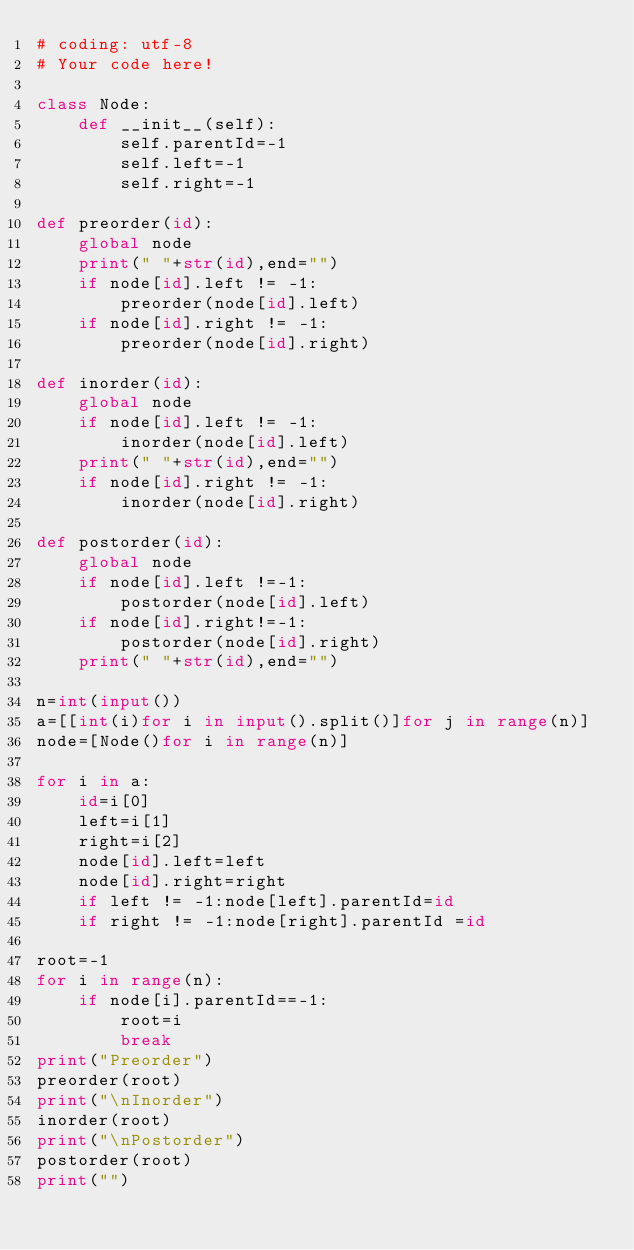Convert code to text. <code><loc_0><loc_0><loc_500><loc_500><_Python_># coding: utf-8
# Your code here!

class Node:
    def __init__(self):
        self.parentId=-1
        self.left=-1
        self.right=-1

def preorder(id):
    global node
    print(" "+str(id),end="")
    if node[id].left != -1:
        preorder(node[id].left)
    if node[id].right != -1:
        preorder(node[id].right)
    
def inorder(id):
    global node
    if node[id].left != -1:
        inorder(node[id].left)
    print(" "+str(id),end="")
    if node[id].right != -1:
        inorder(node[id].right)

def postorder(id):
    global node
    if node[id].left !=-1:
        postorder(node[id].left)
    if node[id].right!=-1:
        postorder(node[id].right)
    print(" "+str(id),end="")

n=int(input())
a=[[int(i)for i in input().split()]for j in range(n)]
node=[Node()for i in range(n)]

for i in a:
    id=i[0]
    left=i[1]
    right=i[2]
    node[id].left=left
    node[id].right=right
    if left != -1:node[left].parentId=id
    if right != -1:node[right].parentId =id

root=-1
for i in range(n):
    if node[i].parentId==-1:
        root=i
        break
print("Preorder")
preorder(root)
print("\nInorder")
inorder(root)
print("\nPostorder")
postorder(root)
print("")
</code> 